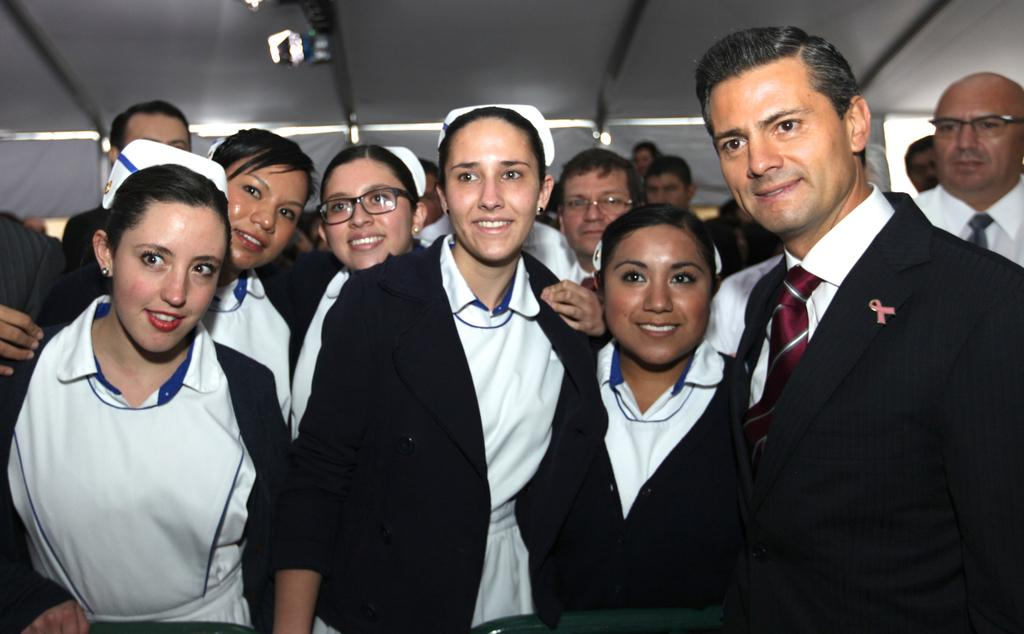What is happening in the image involving the group of people? The people in the image are standing and smiling. What can be seen in the background of the image? There is a tent visible at the top of the image. What type of lighting is present in the image? There are lights in the image. What objects are in the foreground of the image? Chairs are present in the foreground of the image. What word does the owner of the tent use to describe the memory of this event? There is no owner of the tent mentioned in the image, nor is there any indication of a memory or a specific word used to describe it. 